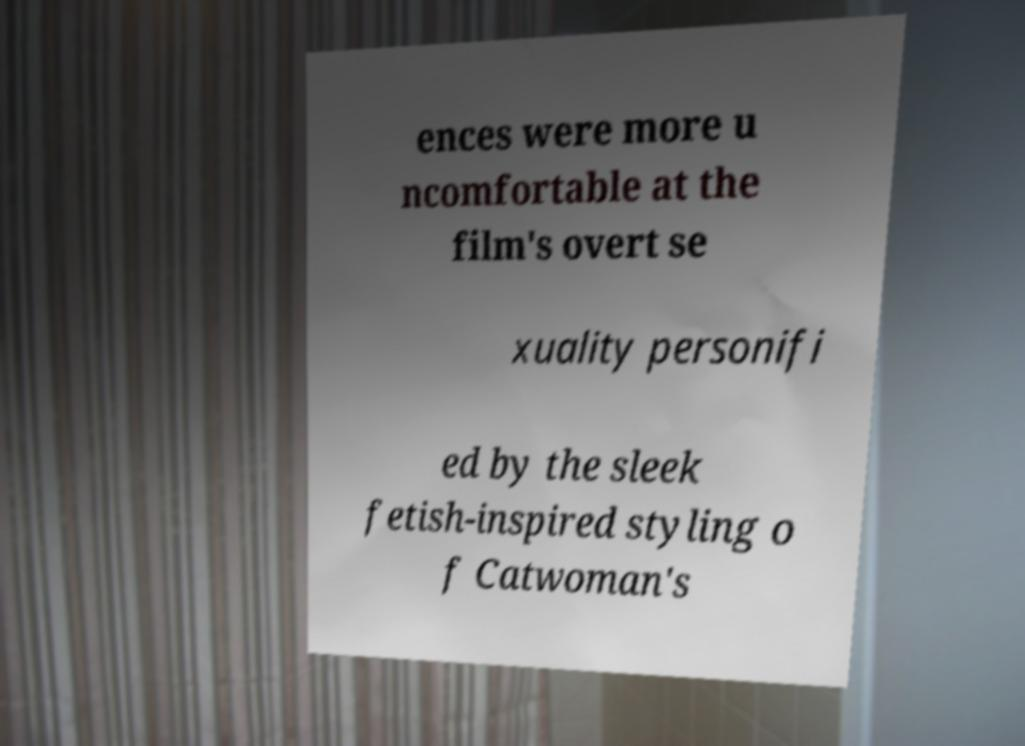Can you read and provide the text displayed in the image?This photo seems to have some interesting text. Can you extract and type it out for me? ences were more u ncomfortable at the film's overt se xuality personifi ed by the sleek fetish-inspired styling o f Catwoman's 